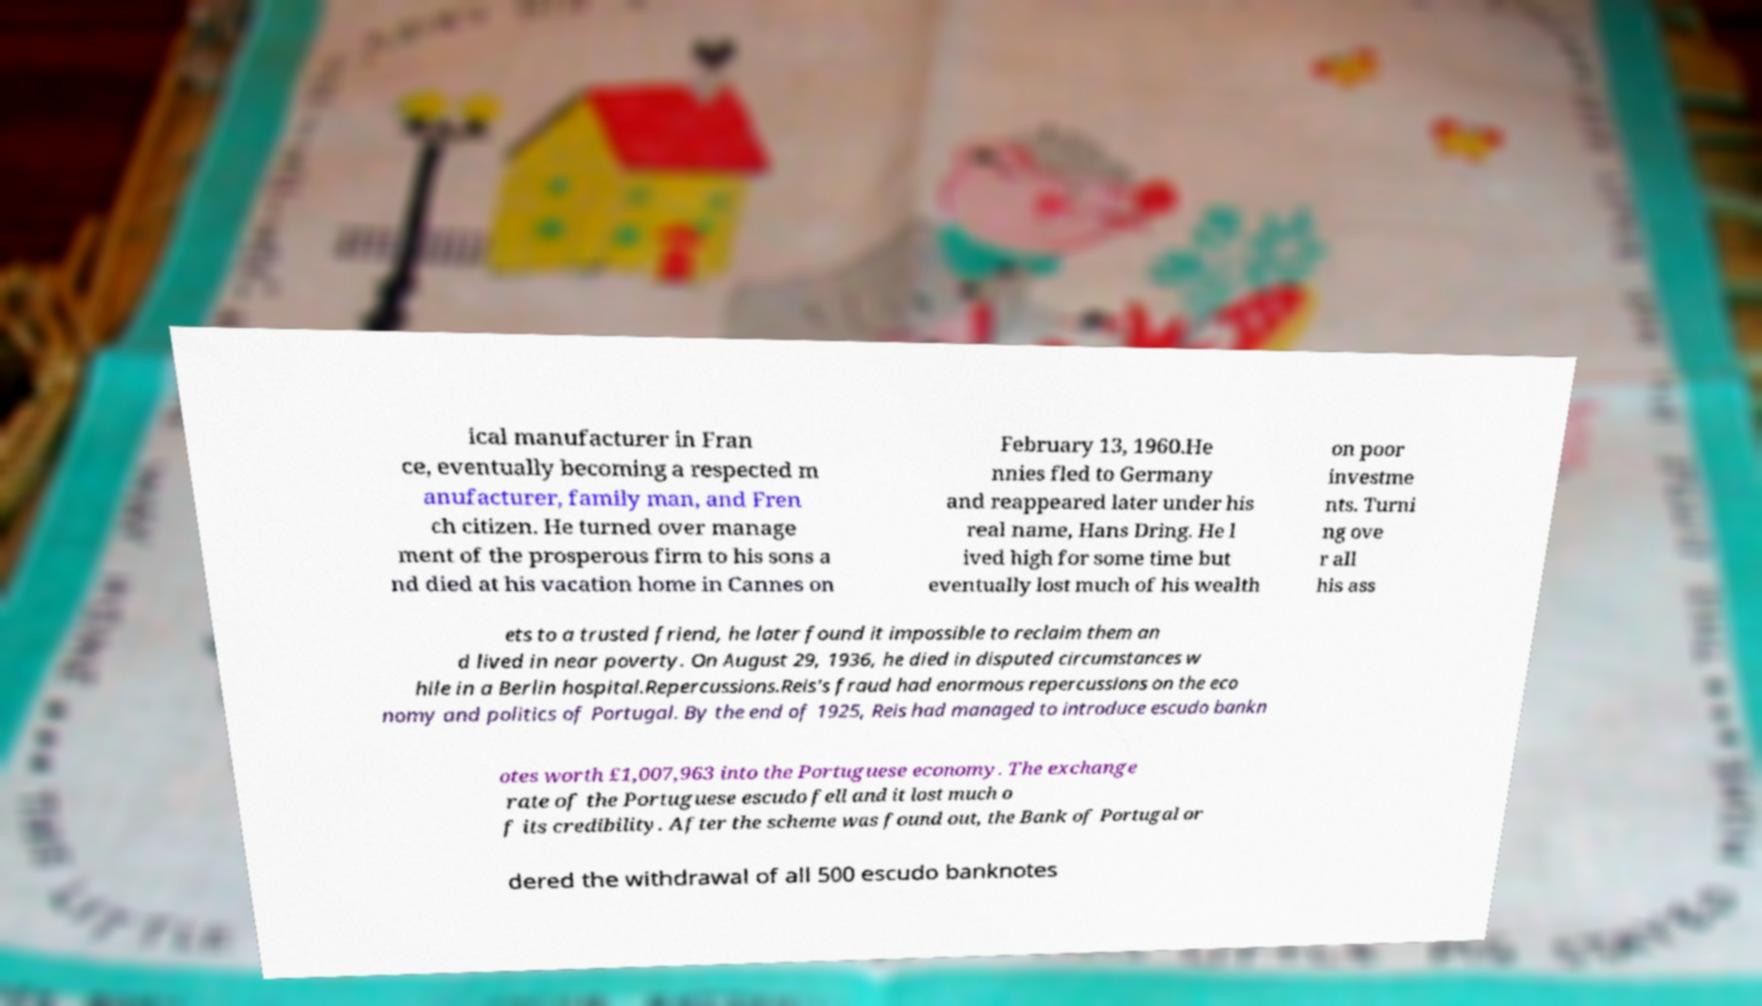Could you extract and type out the text from this image? ical manufacturer in Fran ce, eventually becoming a respected m anufacturer, family man, and Fren ch citizen. He turned over manage ment of the prosperous firm to his sons a nd died at his vacation home in Cannes on February 13, 1960.He nnies fled to Germany and reappeared later under his real name, Hans Dring. He l ived high for some time but eventually lost much of his wealth on poor investme nts. Turni ng ove r all his ass ets to a trusted friend, he later found it impossible to reclaim them an d lived in near poverty. On August 29, 1936, he died in disputed circumstances w hile in a Berlin hospital.Repercussions.Reis's fraud had enormous repercussions on the eco nomy and politics of Portugal. By the end of 1925, Reis had managed to introduce escudo bankn otes worth £1,007,963 into the Portuguese economy. The exchange rate of the Portuguese escudo fell and it lost much o f its credibility. After the scheme was found out, the Bank of Portugal or dered the withdrawal of all 500 escudo banknotes 